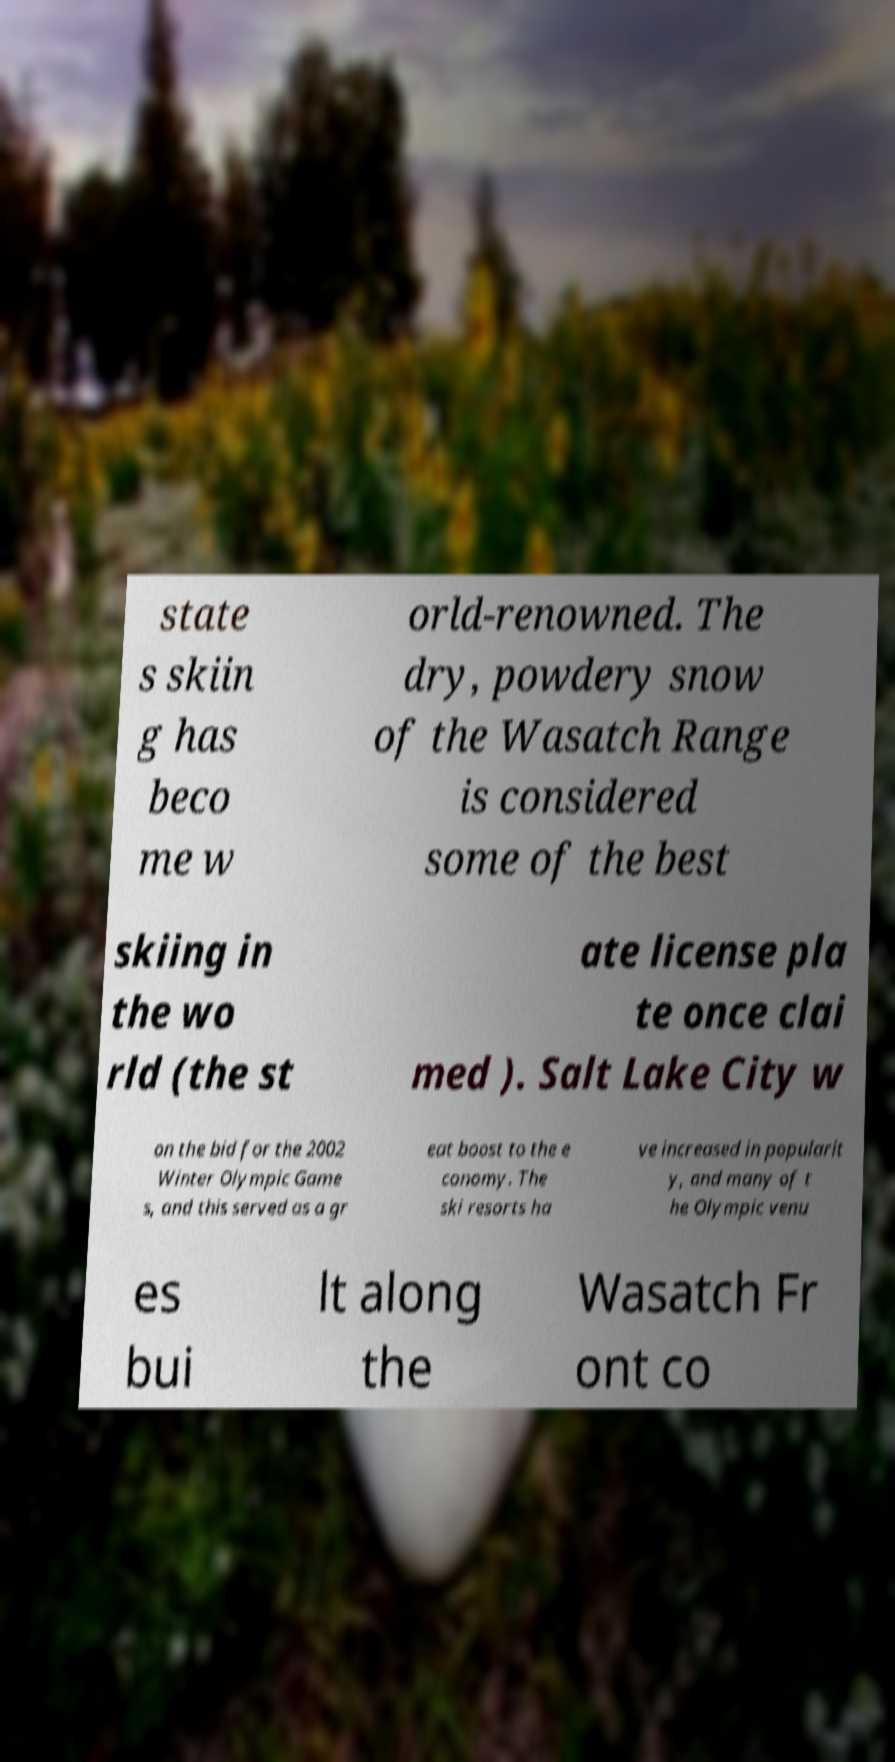Please read and relay the text visible in this image. What does it say? state s skiin g has beco me w orld-renowned. The dry, powdery snow of the Wasatch Range is considered some of the best skiing in the wo rld (the st ate license pla te once clai med ). Salt Lake City w on the bid for the 2002 Winter Olympic Game s, and this served as a gr eat boost to the e conomy. The ski resorts ha ve increased in popularit y, and many of t he Olympic venu es bui lt along the Wasatch Fr ont co 